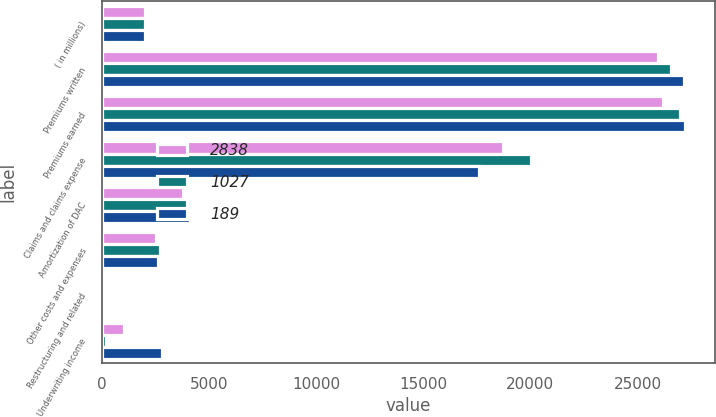Convert chart to OTSL. <chart><loc_0><loc_0><loc_500><loc_500><stacked_bar_chart><ecel><fcel>( in millions)<fcel>Premiums written<fcel>Premiums earned<fcel>Claims and claims expense<fcel>Amortization of DAC<fcel>Other costs and expenses<fcel>Restructuring and related<fcel>Underwriting income<nl><fcel>2838<fcel>2009<fcel>25972<fcel>26195<fcel>18722<fcel>3789<fcel>2552<fcel>105<fcel>1027<nl><fcel>1027<fcel>2008<fcel>26584<fcel>26967<fcel>20046<fcel>3975<fcel>2735<fcel>22<fcel>189<nl><fcel>189<fcel>2007<fcel>27183<fcel>27232<fcel>17620<fcel>4121<fcel>2626<fcel>27<fcel>2838<nl></chart> 